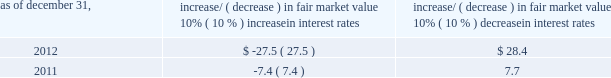Item 7a .
Quantitative and qualitative disclosures about market risk ( amounts in millions ) in the normal course of business , we are exposed to market risks related to interest rates , foreign currency rates and certain balance sheet items .
From time to time , we use derivative instruments , pursuant to established guidelines and policies , to manage some portion of these risks .
Derivative instruments utilized in our hedging activities are viewed as risk management tools and are not used for trading or speculative purposes .
Interest rates our exposure to market risk for changes in interest rates relates primarily to the fair market value and cash flows of our debt obligations .
The majority of our debt ( approximately 93% ( 93 % ) and 91% ( 91 % ) as of december 31 , 2012 and 2011 , respectively ) bears interest at fixed rates .
We do have debt with variable interest rates , but a 10% ( 10 % ) increase or decrease in interest rates would not be material to our interest expense or cash flows .
The fair market value of our debt is sensitive to changes in interest rates , and the impact of a 10% ( 10 % ) change in interest rates is summarized below .
Increase/ ( decrease ) in fair market value as of december 31 , 10% ( 10 % ) increase in interest rates 10% ( 10 % ) decrease in interest rates .
We have used interest rate swaps for risk management purposes to manage our exposure to changes in interest rates .
During 2012 , we entered into and exited forward-starting interest rate swap agreements to effectively lock in the benchmark rate related to our 3.75% ( 3.75 % ) senior notes due 2023 , which we issued in november 2012 .
We do not have any interest rate swaps outstanding as of december 31 , 2012 .
We had $ 2590.8 of cash , cash equivalents and marketable securities as of december 31 , 2012 that we generally invest in conservative , short-term investment-grade securities .
The interest income generated from these investments is subject to both domestic and foreign interest rate movements .
During 2012 and 2011 , we had interest income of $ 29.5 and $ 37.8 , respectively .
Based on our 2012 results , a 100 basis point increase or decrease in interest rates would affect our interest income by approximately $ 26.0 , assuming that all cash , cash equivalents and marketable securities are impacted in the same manner and balances remain constant from year-end 2012 levels .
Foreign currency rates we are subject to translation and transaction risks related to changes in foreign currency exchange rates .
Since we report revenues and expenses in u.s .
Dollars , changes in exchange rates may either positively or negatively affect our consolidated revenues and expenses ( as expressed in u.s .
Dollars ) from foreign operations .
The primary foreign currencies that impacted our results during 2012 were the brazilian real , euro , indian rupee and the south african rand .
Based on 2012 exchange rates and operating results , if the u.s .
Dollar were to strengthen or weaken by 10% ( 10 % ) , we currently estimate operating income would decrease or increase between 3% ( 3 % ) and 5% ( 5 % ) , assuming that all currencies are impacted in the same manner and our international revenue and expenses remain constant at 2012 levels .
The functional currency of our foreign operations is generally their respective local currency .
Assets and liabilities are translated at the exchange rates in effect at the balance sheet date , and revenues and expenses are translated at the average exchange rates during the period presented .
The resulting translation adjustments are recorded as a component of accumulated other comprehensive loss , net of tax , in the stockholders 2019 equity section of our consolidated balance sheets .
Our foreign subsidiaries generally collect revenues and pay expenses in their functional currency , mitigating transaction risk .
However , certain subsidiaries may enter into transactions in currencies other than their functional currency .
Assets and liabilities denominated in currencies other than the functional currency are susceptible to movements in foreign currency until final settlement .
Currency transaction gains or losses primarily arising from transactions in currencies other than the functional currency are included in office and general expenses .
We have not entered into a material amount of foreign currency forward exchange contracts or other derivative financial instruments to hedge the effects of potential adverse fluctuations in foreign currency exchange rates. .
What was the ratio of the interest income from 2012 to 2011? 
Computations: (29.5 / 37.8)
Answer: 0.78042. 